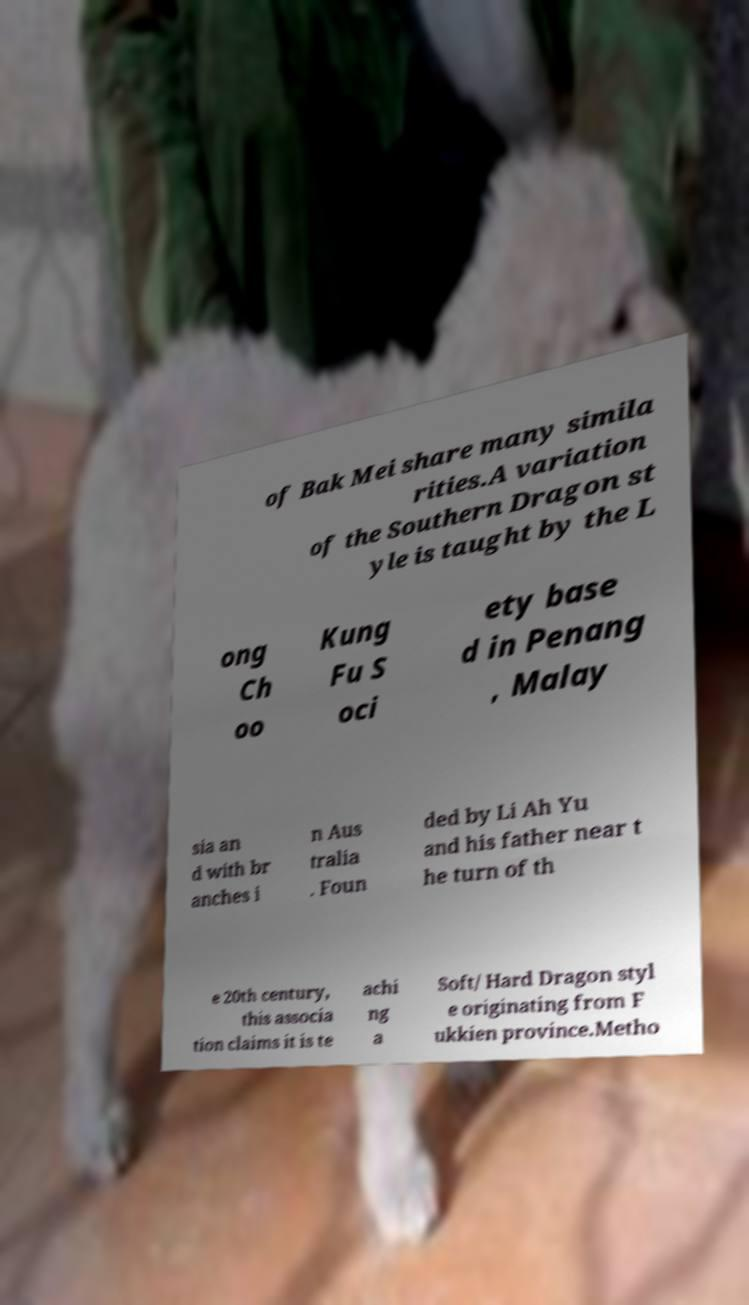There's text embedded in this image that I need extracted. Can you transcribe it verbatim? of Bak Mei share many simila rities.A variation of the Southern Dragon st yle is taught by the L ong Ch oo Kung Fu S oci ety base d in Penang , Malay sia an d with br anches i n Aus tralia . Foun ded by Li Ah Yu and his father near t he turn of th e 20th century, this associa tion claims it is te achi ng a Soft/ Hard Dragon styl e originating from F ukkien province.Metho 